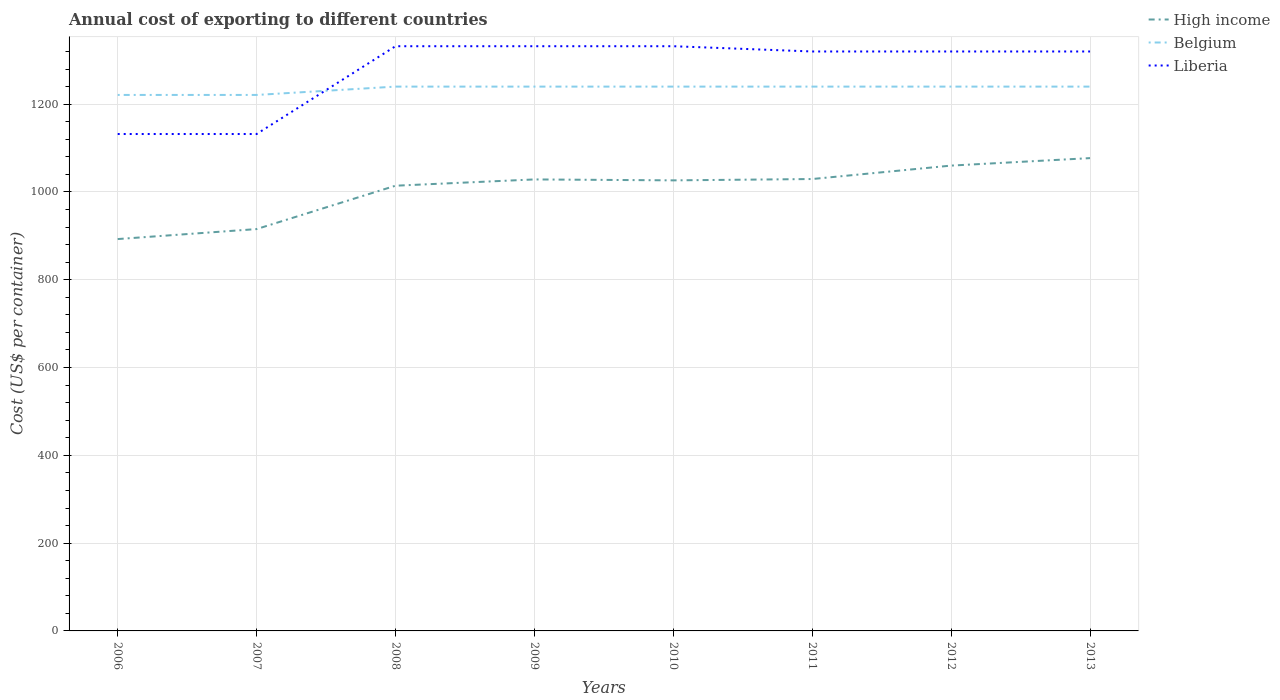Is the number of lines equal to the number of legend labels?
Provide a succinct answer. Yes. Across all years, what is the maximum total annual cost of exporting in High income?
Provide a succinct answer. 892.68. What is the difference between the highest and the second highest total annual cost of exporting in High income?
Give a very brief answer. 184.42. How many lines are there?
Your response must be concise. 3. How many years are there in the graph?
Your answer should be compact. 8. Does the graph contain any zero values?
Your answer should be very brief. No. How many legend labels are there?
Provide a succinct answer. 3. What is the title of the graph?
Make the answer very short. Annual cost of exporting to different countries. What is the label or title of the Y-axis?
Offer a terse response. Cost (US$ per container). What is the Cost (US$ per container) in High income in 2006?
Keep it short and to the point. 892.68. What is the Cost (US$ per container) in Belgium in 2006?
Your response must be concise. 1221. What is the Cost (US$ per container) in Liberia in 2006?
Make the answer very short. 1132. What is the Cost (US$ per container) in High income in 2007?
Provide a short and direct response. 915.43. What is the Cost (US$ per container) in Belgium in 2007?
Give a very brief answer. 1221. What is the Cost (US$ per container) of Liberia in 2007?
Your answer should be compact. 1132. What is the Cost (US$ per container) of High income in 2008?
Your answer should be compact. 1014.23. What is the Cost (US$ per container) of Belgium in 2008?
Provide a short and direct response. 1240. What is the Cost (US$ per container) of Liberia in 2008?
Make the answer very short. 1332. What is the Cost (US$ per container) in High income in 2009?
Your answer should be very brief. 1028.54. What is the Cost (US$ per container) of Belgium in 2009?
Ensure brevity in your answer.  1240. What is the Cost (US$ per container) in Liberia in 2009?
Give a very brief answer. 1332. What is the Cost (US$ per container) in High income in 2010?
Offer a terse response. 1026.4. What is the Cost (US$ per container) of Belgium in 2010?
Make the answer very short. 1240. What is the Cost (US$ per container) in Liberia in 2010?
Provide a short and direct response. 1332. What is the Cost (US$ per container) of High income in 2011?
Your answer should be compact. 1029.46. What is the Cost (US$ per container) in Belgium in 2011?
Keep it short and to the point. 1240. What is the Cost (US$ per container) in Liberia in 2011?
Ensure brevity in your answer.  1320. What is the Cost (US$ per container) in High income in 2012?
Make the answer very short. 1060.05. What is the Cost (US$ per container) in Belgium in 2012?
Ensure brevity in your answer.  1240. What is the Cost (US$ per container) in Liberia in 2012?
Ensure brevity in your answer.  1320. What is the Cost (US$ per container) of High income in 2013?
Your response must be concise. 1077.1. What is the Cost (US$ per container) in Belgium in 2013?
Provide a short and direct response. 1240. What is the Cost (US$ per container) of Liberia in 2013?
Make the answer very short. 1320. Across all years, what is the maximum Cost (US$ per container) in High income?
Give a very brief answer. 1077.1. Across all years, what is the maximum Cost (US$ per container) of Belgium?
Provide a short and direct response. 1240. Across all years, what is the maximum Cost (US$ per container) in Liberia?
Your answer should be compact. 1332. Across all years, what is the minimum Cost (US$ per container) in High income?
Give a very brief answer. 892.68. Across all years, what is the minimum Cost (US$ per container) of Belgium?
Offer a very short reply. 1221. Across all years, what is the minimum Cost (US$ per container) in Liberia?
Your answer should be compact. 1132. What is the total Cost (US$ per container) in High income in the graph?
Give a very brief answer. 8043.89. What is the total Cost (US$ per container) of Belgium in the graph?
Ensure brevity in your answer.  9882. What is the total Cost (US$ per container) in Liberia in the graph?
Make the answer very short. 1.02e+04. What is the difference between the Cost (US$ per container) in High income in 2006 and that in 2007?
Provide a succinct answer. -22.75. What is the difference between the Cost (US$ per container) in Belgium in 2006 and that in 2007?
Your answer should be compact. 0. What is the difference between the Cost (US$ per container) in High income in 2006 and that in 2008?
Your answer should be very brief. -121.55. What is the difference between the Cost (US$ per container) in Liberia in 2006 and that in 2008?
Keep it short and to the point. -200. What is the difference between the Cost (US$ per container) in High income in 2006 and that in 2009?
Provide a succinct answer. -135.86. What is the difference between the Cost (US$ per container) of Liberia in 2006 and that in 2009?
Give a very brief answer. -200. What is the difference between the Cost (US$ per container) of High income in 2006 and that in 2010?
Keep it short and to the point. -133.72. What is the difference between the Cost (US$ per container) in Belgium in 2006 and that in 2010?
Your response must be concise. -19. What is the difference between the Cost (US$ per container) of Liberia in 2006 and that in 2010?
Offer a very short reply. -200. What is the difference between the Cost (US$ per container) of High income in 2006 and that in 2011?
Your response must be concise. -136.78. What is the difference between the Cost (US$ per container) of Liberia in 2006 and that in 2011?
Make the answer very short. -188. What is the difference between the Cost (US$ per container) of High income in 2006 and that in 2012?
Offer a terse response. -167.37. What is the difference between the Cost (US$ per container) in Belgium in 2006 and that in 2012?
Make the answer very short. -19. What is the difference between the Cost (US$ per container) in Liberia in 2006 and that in 2012?
Your response must be concise. -188. What is the difference between the Cost (US$ per container) of High income in 2006 and that in 2013?
Provide a short and direct response. -184.42. What is the difference between the Cost (US$ per container) in Belgium in 2006 and that in 2013?
Offer a terse response. -19. What is the difference between the Cost (US$ per container) of Liberia in 2006 and that in 2013?
Keep it short and to the point. -188. What is the difference between the Cost (US$ per container) in High income in 2007 and that in 2008?
Offer a very short reply. -98.8. What is the difference between the Cost (US$ per container) of Belgium in 2007 and that in 2008?
Provide a succinct answer. -19. What is the difference between the Cost (US$ per container) in Liberia in 2007 and that in 2008?
Provide a short and direct response. -200. What is the difference between the Cost (US$ per container) in High income in 2007 and that in 2009?
Offer a terse response. -113.12. What is the difference between the Cost (US$ per container) in Liberia in 2007 and that in 2009?
Offer a terse response. -200. What is the difference between the Cost (US$ per container) of High income in 2007 and that in 2010?
Provide a succinct answer. -110.97. What is the difference between the Cost (US$ per container) of Belgium in 2007 and that in 2010?
Your answer should be very brief. -19. What is the difference between the Cost (US$ per container) of Liberia in 2007 and that in 2010?
Your answer should be very brief. -200. What is the difference between the Cost (US$ per container) in High income in 2007 and that in 2011?
Give a very brief answer. -114.03. What is the difference between the Cost (US$ per container) in Liberia in 2007 and that in 2011?
Your answer should be very brief. -188. What is the difference between the Cost (US$ per container) of High income in 2007 and that in 2012?
Give a very brief answer. -144.62. What is the difference between the Cost (US$ per container) in Liberia in 2007 and that in 2012?
Provide a succinct answer. -188. What is the difference between the Cost (US$ per container) in High income in 2007 and that in 2013?
Give a very brief answer. -161.67. What is the difference between the Cost (US$ per container) of Belgium in 2007 and that in 2013?
Offer a terse response. -19. What is the difference between the Cost (US$ per container) of Liberia in 2007 and that in 2013?
Offer a very short reply. -188. What is the difference between the Cost (US$ per container) of High income in 2008 and that in 2009?
Give a very brief answer. -14.32. What is the difference between the Cost (US$ per container) in High income in 2008 and that in 2010?
Keep it short and to the point. -12.18. What is the difference between the Cost (US$ per container) of High income in 2008 and that in 2011?
Provide a short and direct response. -15.23. What is the difference between the Cost (US$ per container) of High income in 2008 and that in 2012?
Keep it short and to the point. -45.82. What is the difference between the Cost (US$ per container) in Belgium in 2008 and that in 2012?
Make the answer very short. 0. What is the difference between the Cost (US$ per container) of High income in 2008 and that in 2013?
Make the answer very short. -62.87. What is the difference between the Cost (US$ per container) in Belgium in 2008 and that in 2013?
Offer a terse response. 0. What is the difference between the Cost (US$ per container) in High income in 2009 and that in 2010?
Provide a succinct answer. 2.14. What is the difference between the Cost (US$ per container) of Belgium in 2009 and that in 2010?
Offer a very short reply. 0. What is the difference between the Cost (US$ per container) of Liberia in 2009 and that in 2010?
Make the answer very short. 0. What is the difference between the Cost (US$ per container) of High income in 2009 and that in 2011?
Provide a succinct answer. -0.91. What is the difference between the Cost (US$ per container) of Belgium in 2009 and that in 2011?
Your response must be concise. 0. What is the difference between the Cost (US$ per container) of Liberia in 2009 and that in 2011?
Your answer should be very brief. 12. What is the difference between the Cost (US$ per container) of High income in 2009 and that in 2012?
Provide a short and direct response. -31.51. What is the difference between the Cost (US$ per container) of Belgium in 2009 and that in 2012?
Make the answer very short. 0. What is the difference between the Cost (US$ per container) of High income in 2009 and that in 2013?
Offer a terse response. -48.55. What is the difference between the Cost (US$ per container) in Liberia in 2009 and that in 2013?
Ensure brevity in your answer.  12. What is the difference between the Cost (US$ per container) in High income in 2010 and that in 2011?
Provide a succinct answer. -3.05. What is the difference between the Cost (US$ per container) in High income in 2010 and that in 2012?
Provide a succinct answer. -33.65. What is the difference between the Cost (US$ per container) of Belgium in 2010 and that in 2012?
Your response must be concise. 0. What is the difference between the Cost (US$ per container) in Liberia in 2010 and that in 2012?
Offer a very short reply. 12. What is the difference between the Cost (US$ per container) in High income in 2010 and that in 2013?
Your answer should be very brief. -50.69. What is the difference between the Cost (US$ per container) of Liberia in 2010 and that in 2013?
Your answer should be compact. 12. What is the difference between the Cost (US$ per container) of High income in 2011 and that in 2012?
Your answer should be very brief. -30.59. What is the difference between the Cost (US$ per container) of Liberia in 2011 and that in 2012?
Offer a terse response. 0. What is the difference between the Cost (US$ per container) of High income in 2011 and that in 2013?
Your answer should be compact. -47.64. What is the difference between the Cost (US$ per container) of Belgium in 2011 and that in 2013?
Your answer should be very brief. 0. What is the difference between the Cost (US$ per container) in High income in 2012 and that in 2013?
Provide a short and direct response. -17.05. What is the difference between the Cost (US$ per container) in Liberia in 2012 and that in 2013?
Your answer should be very brief. 0. What is the difference between the Cost (US$ per container) in High income in 2006 and the Cost (US$ per container) in Belgium in 2007?
Your answer should be compact. -328.32. What is the difference between the Cost (US$ per container) in High income in 2006 and the Cost (US$ per container) in Liberia in 2007?
Provide a short and direct response. -239.32. What is the difference between the Cost (US$ per container) of Belgium in 2006 and the Cost (US$ per container) of Liberia in 2007?
Your response must be concise. 89. What is the difference between the Cost (US$ per container) of High income in 2006 and the Cost (US$ per container) of Belgium in 2008?
Make the answer very short. -347.32. What is the difference between the Cost (US$ per container) in High income in 2006 and the Cost (US$ per container) in Liberia in 2008?
Keep it short and to the point. -439.32. What is the difference between the Cost (US$ per container) of Belgium in 2006 and the Cost (US$ per container) of Liberia in 2008?
Keep it short and to the point. -111. What is the difference between the Cost (US$ per container) in High income in 2006 and the Cost (US$ per container) in Belgium in 2009?
Provide a short and direct response. -347.32. What is the difference between the Cost (US$ per container) of High income in 2006 and the Cost (US$ per container) of Liberia in 2009?
Your answer should be very brief. -439.32. What is the difference between the Cost (US$ per container) in Belgium in 2006 and the Cost (US$ per container) in Liberia in 2009?
Offer a very short reply. -111. What is the difference between the Cost (US$ per container) of High income in 2006 and the Cost (US$ per container) of Belgium in 2010?
Offer a terse response. -347.32. What is the difference between the Cost (US$ per container) of High income in 2006 and the Cost (US$ per container) of Liberia in 2010?
Ensure brevity in your answer.  -439.32. What is the difference between the Cost (US$ per container) in Belgium in 2006 and the Cost (US$ per container) in Liberia in 2010?
Provide a succinct answer. -111. What is the difference between the Cost (US$ per container) in High income in 2006 and the Cost (US$ per container) in Belgium in 2011?
Make the answer very short. -347.32. What is the difference between the Cost (US$ per container) of High income in 2006 and the Cost (US$ per container) of Liberia in 2011?
Your answer should be very brief. -427.32. What is the difference between the Cost (US$ per container) of Belgium in 2006 and the Cost (US$ per container) of Liberia in 2011?
Make the answer very short. -99. What is the difference between the Cost (US$ per container) in High income in 2006 and the Cost (US$ per container) in Belgium in 2012?
Provide a short and direct response. -347.32. What is the difference between the Cost (US$ per container) of High income in 2006 and the Cost (US$ per container) of Liberia in 2012?
Provide a succinct answer. -427.32. What is the difference between the Cost (US$ per container) of Belgium in 2006 and the Cost (US$ per container) of Liberia in 2012?
Make the answer very short. -99. What is the difference between the Cost (US$ per container) in High income in 2006 and the Cost (US$ per container) in Belgium in 2013?
Keep it short and to the point. -347.32. What is the difference between the Cost (US$ per container) of High income in 2006 and the Cost (US$ per container) of Liberia in 2013?
Give a very brief answer. -427.32. What is the difference between the Cost (US$ per container) of Belgium in 2006 and the Cost (US$ per container) of Liberia in 2013?
Your response must be concise. -99. What is the difference between the Cost (US$ per container) in High income in 2007 and the Cost (US$ per container) in Belgium in 2008?
Keep it short and to the point. -324.57. What is the difference between the Cost (US$ per container) in High income in 2007 and the Cost (US$ per container) in Liberia in 2008?
Make the answer very short. -416.57. What is the difference between the Cost (US$ per container) of Belgium in 2007 and the Cost (US$ per container) of Liberia in 2008?
Give a very brief answer. -111. What is the difference between the Cost (US$ per container) of High income in 2007 and the Cost (US$ per container) of Belgium in 2009?
Give a very brief answer. -324.57. What is the difference between the Cost (US$ per container) in High income in 2007 and the Cost (US$ per container) in Liberia in 2009?
Offer a terse response. -416.57. What is the difference between the Cost (US$ per container) in Belgium in 2007 and the Cost (US$ per container) in Liberia in 2009?
Your answer should be compact. -111. What is the difference between the Cost (US$ per container) of High income in 2007 and the Cost (US$ per container) of Belgium in 2010?
Your response must be concise. -324.57. What is the difference between the Cost (US$ per container) of High income in 2007 and the Cost (US$ per container) of Liberia in 2010?
Make the answer very short. -416.57. What is the difference between the Cost (US$ per container) in Belgium in 2007 and the Cost (US$ per container) in Liberia in 2010?
Offer a very short reply. -111. What is the difference between the Cost (US$ per container) in High income in 2007 and the Cost (US$ per container) in Belgium in 2011?
Offer a terse response. -324.57. What is the difference between the Cost (US$ per container) in High income in 2007 and the Cost (US$ per container) in Liberia in 2011?
Offer a terse response. -404.57. What is the difference between the Cost (US$ per container) of Belgium in 2007 and the Cost (US$ per container) of Liberia in 2011?
Give a very brief answer. -99. What is the difference between the Cost (US$ per container) of High income in 2007 and the Cost (US$ per container) of Belgium in 2012?
Make the answer very short. -324.57. What is the difference between the Cost (US$ per container) of High income in 2007 and the Cost (US$ per container) of Liberia in 2012?
Provide a short and direct response. -404.57. What is the difference between the Cost (US$ per container) in Belgium in 2007 and the Cost (US$ per container) in Liberia in 2012?
Ensure brevity in your answer.  -99. What is the difference between the Cost (US$ per container) of High income in 2007 and the Cost (US$ per container) of Belgium in 2013?
Give a very brief answer. -324.57. What is the difference between the Cost (US$ per container) in High income in 2007 and the Cost (US$ per container) in Liberia in 2013?
Offer a very short reply. -404.57. What is the difference between the Cost (US$ per container) in Belgium in 2007 and the Cost (US$ per container) in Liberia in 2013?
Make the answer very short. -99. What is the difference between the Cost (US$ per container) in High income in 2008 and the Cost (US$ per container) in Belgium in 2009?
Keep it short and to the point. -225.77. What is the difference between the Cost (US$ per container) of High income in 2008 and the Cost (US$ per container) of Liberia in 2009?
Make the answer very short. -317.77. What is the difference between the Cost (US$ per container) in Belgium in 2008 and the Cost (US$ per container) in Liberia in 2009?
Provide a short and direct response. -92. What is the difference between the Cost (US$ per container) of High income in 2008 and the Cost (US$ per container) of Belgium in 2010?
Keep it short and to the point. -225.77. What is the difference between the Cost (US$ per container) in High income in 2008 and the Cost (US$ per container) in Liberia in 2010?
Your answer should be very brief. -317.77. What is the difference between the Cost (US$ per container) of Belgium in 2008 and the Cost (US$ per container) of Liberia in 2010?
Your response must be concise. -92. What is the difference between the Cost (US$ per container) of High income in 2008 and the Cost (US$ per container) of Belgium in 2011?
Offer a terse response. -225.77. What is the difference between the Cost (US$ per container) of High income in 2008 and the Cost (US$ per container) of Liberia in 2011?
Keep it short and to the point. -305.77. What is the difference between the Cost (US$ per container) of Belgium in 2008 and the Cost (US$ per container) of Liberia in 2011?
Your answer should be compact. -80. What is the difference between the Cost (US$ per container) of High income in 2008 and the Cost (US$ per container) of Belgium in 2012?
Offer a terse response. -225.77. What is the difference between the Cost (US$ per container) of High income in 2008 and the Cost (US$ per container) of Liberia in 2012?
Your answer should be very brief. -305.77. What is the difference between the Cost (US$ per container) in Belgium in 2008 and the Cost (US$ per container) in Liberia in 2012?
Your response must be concise. -80. What is the difference between the Cost (US$ per container) of High income in 2008 and the Cost (US$ per container) of Belgium in 2013?
Your answer should be very brief. -225.77. What is the difference between the Cost (US$ per container) in High income in 2008 and the Cost (US$ per container) in Liberia in 2013?
Keep it short and to the point. -305.77. What is the difference between the Cost (US$ per container) in Belgium in 2008 and the Cost (US$ per container) in Liberia in 2013?
Provide a succinct answer. -80. What is the difference between the Cost (US$ per container) in High income in 2009 and the Cost (US$ per container) in Belgium in 2010?
Ensure brevity in your answer.  -211.46. What is the difference between the Cost (US$ per container) of High income in 2009 and the Cost (US$ per container) of Liberia in 2010?
Ensure brevity in your answer.  -303.46. What is the difference between the Cost (US$ per container) in Belgium in 2009 and the Cost (US$ per container) in Liberia in 2010?
Your answer should be compact. -92. What is the difference between the Cost (US$ per container) of High income in 2009 and the Cost (US$ per container) of Belgium in 2011?
Provide a succinct answer. -211.46. What is the difference between the Cost (US$ per container) in High income in 2009 and the Cost (US$ per container) in Liberia in 2011?
Keep it short and to the point. -291.46. What is the difference between the Cost (US$ per container) of Belgium in 2009 and the Cost (US$ per container) of Liberia in 2011?
Ensure brevity in your answer.  -80. What is the difference between the Cost (US$ per container) of High income in 2009 and the Cost (US$ per container) of Belgium in 2012?
Your answer should be very brief. -211.46. What is the difference between the Cost (US$ per container) in High income in 2009 and the Cost (US$ per container) in Liberia in 2012?
Your answer should be very brief. -291.46. What is the difference between the Cost (US$ per container) of Belgium in 2009 and the Cost (US$ per container) of Liberia in 2012?
Ensure brevity in your answer.  -80. What is the difference between the Cost (US$ per container) in High income in 2009 and the Cost (US$ per container) in Belgium in 2013?
Your answer should be compact. -211.46. What is the difference between the Cost (US$ per container) in High income in 2009 and the Cost (US$ per container) in Liberia in 2013?
Offer a terse response. -291.46. What is the difference between the Cost (US$ per container) of Belgium in 2009 and the Cost (US$ per container) of Liberia in 2013?
Offer a terse response. -80. What is the difference between the Cost (US$ per container) of High income in 2010 and the Cost (US$ per container) of Belgium in 2011?
Keep it short and to the point. -213.6. What is the difference between the Cost (US$ per container) in High income in 2010 and the Cost (US$ per container) in Liberia in 2011?
Provide a succinct answer. -293.6. What is the difference between the Cost (US$ per container) of Belgium in 2010 and the Cost (US$ per container) of Liberia in 2011?
Ensure brevity in your answer.  -80. What is the difference between the Cost (US$ per container) of High income in 2010 and the Cost (US$ per container) of Belgium in 2012?
Offer a terse response. -213.6. What is the difference between the Cost (US$ per container) of High income in 2010 and the Cost (US$ per container) of Liberia in 2012?
Give a very brief answer. -293.6. What is the difference between the Cost (US$ per container) of Belgium in 2010 and the Cost (US$ per container) of Liberia in 2012?
Ensure brevity in your answer.  -80. What is the difference between the Cost (US$ per container) of High income in 2010 and the Cost (US$ per container) of Belgium in 2013?
Offer a terse response. -213.6. What is the difference between the Cost (US$ per container) in High income in 2010 and the Cost (US$ per container) in Liberia in 2013?
Provide a short and direct response. -293.6. What is the difference between the Cost (US$ per container) of Belgium in 2010 and the Cost (US$ per container) of Liberia in 2013?
Your response must be concise. -80. What is the difference between the Cost (US$ per container) in High income in 2011 and the Cost (US$ per container) in Belgium in 2012?
Provide a succinct answer. -210.54. What is the difference between the Cost (US$ per container) of High income in 2011 and the Cost (US$ per container) of Liberia in 2012?
Your response must be concise. -290.54. What is the difference between the Cost (US$ per container) in Belgium in 2011 and the Cost (US$ per container) in Liberia in 2012?
Ensure brevity in your answer.  -80. What is the difference between the Cost (US$ per container) of High income in 2011 and the Cost (US$ per container) of Belgium in 2013?
Your answer should be very brief. -210.54. What is the difference between the Cost (US$ per container) of High income in 2011 and the Cost (US$ per container) of Liberia in 2013?
Make the answer very short. -290.54. What is the difference between the Cost (US$ per container) of Belgium in 2011 and the Cost (US$ per container) of Liberia in 2013?
Provide a short and direct response. -80. What is the difference between the Cost (US$ per container) of High income in 2012 and the Cost (US$ per container) of Belgium in 2013?
Your answer should be very brief. -179.95. What is the difference between the Cost (US$ per container) in High income in 2012 and the Cost (US$ per container) in Liberia in 2013?
Your answer should be compact. -259.95. What is the difference between the Cost (US$ per container) in Belgium in 2012 and the Cost (US$ per container) in Liberia in 2013?
Make the answer very short. -80. What is the average Cost (US$ per container) of High income per year?
Provide a short and direct response. 1005.49. What is the average Cost (US$ per container) in Belgium per year?
Offer a very short reply. 1235.25. What is the average Cost (US$ per container) of Liberia per year?
Your answer should be very brief. 1277.5. In the year 2006, what is the difference between the Cost (US$ per container) of High income and Cost (US$ per container) of Belgium?
Your answer should be compact. -328.32. In the year 2006, what is the difference between the Cost (US$ per container) of High income and Cost (US$ per container) of Liberia?
Your answer should be very brief. -239.32. In the year 2006, what is the difference between the Cost (US$ per container) in Belgium and Cost (US$ per container) in Liberia?
Give a very brief answer. 89. In the year 2007, what is the difference between the Cost (US$ per container) of High income and Cost (US$ per container) of Belgium?
Keep it short and to the point. -305.57. In the year 2007, what is the difference between the Cost (US$ per container) in High income and Cost (US$ per container) in Liberia?
Give a very brief answer. -216.57. In the year 2007, what is the difference between the Cost (US$ per container) of Belgium and Cost (US$ per container) of Liberia?
Provide a succinct answer. 89. In the year 2008, what is the difference between the Cost (US$ per container) in High income and Cost (US$ per container) in Belgium?
Give a very brief answer. -225.77. In the year 2008, what is the difference between the Cost (US$ per container) of High income and Cost (US$ per container) of Liberia?
Make the answer very short. -317.77. In the year 2008, what is the difference between the Cost (US$ per container) of Belgium and Cost (US$ per container) of Liberia?
Ensure brevity in your answer.  -92. In the year 2009, what is the difference between the Cost (US$ per container) in High income and Cost (US$ per container) in Belgium?
Give a very brief answer. -211.46. In the year 2009, what is the difference between the Cost (US$ per container) of High income and Cost (US$ per container) of Liberia?
Keep it short and to the point. -303.46. In the year 2009, what is the difference between the Cost (US$ per container) in Belgium and Cost (US$ per container) in Liberia?
Give a very brief answer. -92. In the year 2010, what is the difference between the Cost (US$ per container) in High income and Cost (US$ per container) in Belgium?
Make the answer very short. -213.6. In the year 2010, what is the difference between the Cost (US$ per container) in High income and Cost (US$ per container) in Liberia?
Give a very brief answer. -305.6. In the year 2010, what is the difference between the Cost (US$ per container) in Belgium and Cost (US$ per container) in Liberia?
Offer a very short reply. -92. In the year 2011, what is the difference between the Cost (US$ per container) in High income and Cost (US$ per container) in Belgium?
Provide a short and direct response. -210.54. In the year 2011, what is the difference between the Cost (US$ per container) in High income and Cost (US$ per container) in Liberia?
Your response must be concise. -290.54. In the year 2011, what is the difference between the Cost (US$ per container) of Belgium and Cost (US$ per container) of Liberia?
Keep it short and to the point. -80. In the year 2012, what is the difference between the Cost (US$ per container) of High income and Cost (US$ per container) of Belgium?
Provide a succinct answer. -179.95. In the year 2012, what is the difference between the Cost (US$ per container) of High income and Cost (US$ per container) of Liberia?
Offer a very short reply. -259.95. In the year 2012, what is the difference between the Cost (US$ per container) of Belgium and Cost (US$ per container) of Liberia?
Give a very brief answer. -80. In the year 2013, what is the difference between the Cost (US$ per container) of High income and Cost (US$ per container) of Belgium?
Give a very brief answer. -162.9. In the year 2013, what is the difference between the Cost (US$ per container) in High income and Cost (US$ per container) in Liberia?
Your response must be concise. -242.9. In the year 2013, what is the difference between the Cost (US$ per container) of Belgium and Cost (US$ per container) of Liberia?
Provide a succinct answer. -80. What is the ratio of the Cost (US$ per container) in High income in 2006 to that in 2007?
Provide a succinct answer. 0.98. What is the ratio of the Cost (US$ per container) of High income in 2006 to that in 2008?
Provide a succinct answer. 0.88. What is the ratio of the Cost (US$ per container) in Belgium in 2006 to that in 2008?
Your response must be concise. 0.98. What is the ratio of the Cost (US$ per container) in Liberia in 2006 to that in 2008?
Keep it short and to the point. 0.85. What is the ratio of the Cost (US$ per container) in High income in 2006 to that in 2009?
Your answer should be very brief. 0.87. What is the ratio of the Cost (US$ per container) of Belgium in 2006 to that in 2009?
Make the answer very short. 0.98. What is the ratio of the Cost (US$ per container) of Liberia in 2006 to that in 2009?
Provide a short and direct response. 0.85. What is the ratio of the Cost (US$ per container) in High income in 2006 to that in 2010?
Ensure brevity in your answer.  0.87. What is the ratio of the Cost (US$ per container) of Belgium in 2006 to that in 2010?
Offer a very short reply. 0.98. What is the ratio of the Cost (US$ per container) in Liberia in 2006 to that in 2010?
Your response must be concise. 0.85. What is the ratio of the Cost (US$ per container) in High income in 2006 to that in 2011?
Your answer should be compact. 0.87. What is the ratio of the Cost (US$ per container) of Belgium in 2006 to that in 2011?
Your answer should be very brief. 0.98. What is the ratio of the Cost (US$ per container) of Liberia in 2006 to that in 2011?
Offer a very short reply. 0.86. What is the ratio of the Cost (US$ per container) of High income in 2006 to that in 2012?
Your answer should be very brief. 0.84. What is the ratio of the Cost (US$ per container) in Belgium in 2006 to that in 2012?
Give a very brief answer. 0.98. What is the ratio of the Cost (US$ per container) in Liberia in 2006 to that in 2012?
Provide a short and direct response. 0.86. What is the ratio of the Cost (US$ per container) of High income in 2006 to that in 2013?
Keep it short and to the point. 0.83. What is the ratio of the Cost (US$ per container) of Belgium in 2006 to that in 2013?
Ensure brevity in your answer.  0.98. What is the ratio of the Cost (US$ per container) in Liberia in 2006 to that in 2013?
Give a very brief answer. 0.86. What is the ratio of the Cost (US$ per container) in High income in 2007 to that in 2008?
Your response must be concise. 0.9. What is the ratio of the Cost (US$ per container) in Belgium in 2007 to that in 2008?
Make the answer very short. 0.98. What is the ratio of the Cost (US$ per container) of Liberia in 2007 to that in 2008?
Your response must be concise. 0.85. What is the ratio of the Cost (US$ per container) in High income in 2007 to that in 2009?
Your answer should be compact. 0.89. What is the ratio of the Cost (US$ per container) of Belgium in 2007 to that in 2009?
Offer a terse response. 0.98. What is the ratio of the Cost (US$ per container) in Liberia in 2007 to that in 2009?
Give a very brief answer. 0.85. What is the ratio of the Cost (US$ per container) in High income in 2007 to that in 2010?
Your answer should be compact. 0.89. What is the ratio of the Cost (US$ per container) of Belgium in 2007 to that in 2010?
Provide a succinct answer. 0.98. What is the ratio of the Cost (US$ per container) of Liberia in 2007 to that in 2010?
Your answer should be compact. 0.85. What is the ratio of the Cost (US$ per container) in High income in 2007 to that in 2011?
Your answer should be very brief. 0.89. What is the ratio of the Cost (US$ per container) of Belgium in 2007 to that in 2011?
Keep it short and to the point. 0.98. What is the ratio of the Cost (US$ per container) in Liberia in 2007 to that in 2011?
Make the answer very short. 0.86. What is the ratio of the Cost (US$ per container) of High income in 2007 to that in 2012?
Offer a very short reply. 0.86. What is the ratio of the Cost (US$ per container) of Belgium in 2007 to that in 2012?
Your answer should be very brief. 0.98. What is the ratio of the Cost (US$ per container) in Liberia in 2007 to that in 2012?
Provide a succinct answer. 0.86. What is the ratio of the Cost (US$ per container) in High income in 2007 to that in 2013?
Make the answer very short. 0.85. What is the ratio of the Cost (US$ per container) in Belgium in 2007 to that in 2013?
Your answer should be very brief. 0.98. What is the ratio of the Cost (US$ per container) in Liberia in 2007 to that in 2013?
Provide a short and direct response. 0.86. What is the ratio of the Cost (US$ per container) in High income in 2008 to that in 2009?
Make the answer very short. 0.99. What is the ratio of the Cost (US$ per container) in Belgium in 2008 to that in 2009?
Ensure brevity in your answer.  1. What is the ratio of the Cost (US$ per container) of Liberia in 2008 to that in 2009?
Provide a succinct answer. 1. What is the ratio of the Cost (US$ per container) in High income in 2008 to that in 2010?
Provide a short and direct response. 0.99. What is the ratio of the Cost (US$ per container) of Belgium in 2008 to that in 2010?
Your response must be concise. 1. What is the ratio of the Cost (US$ per container) in Liberia in 2008 to that in 2010?
Keep it short and to the point. 1. What is the ratio of the Cost (US$ per container) in High income in 2008 to that in 2011?
Provide a short and direct response. 0.99. What is the ratio of the Cost (US$ per container) of Belgium in 2008 to that in 2011?
Offer a terse response. 1. What is the ratio of the Cost (US$ per container) in Liberia in 2008 to that in 2011?
Offer a very short reply. 1.01. What is the ratio of the Cost (US$ per container) of High income in 2008 to that in 2012?
Ensure brevity in your answer.  0.96. What is the ratio of the Cost (US$ per container) of Belgium in 2008 to that in 2012?
Give a very brief answer. 1. What is the ratio of the Cost (US$ per container) of Liberia in 2008 to that in 2012?
Provide a succinct answer. 1.01. What is the ratio of the Cost (US$ per container) of High income in 2008 to that in 2013?
Your answer should be compact. 0.94. What is the ratio of the Cost (US$ per container) in Belgium in 2008 to that in 2013?
Ensure brevity in your answer.  1. What is the ratio of the Cost (US$ per container) in Liberia in 2008 to that in 2013?
Offer a terse response. 1.01. What is the ratio of the Cost (US$ per container) in Liberia in 2009 to that in 2011?
Offer a very short reply. 1.01. What is the ratio of the Cost (US$ per container) in High income in 2009 to that in 2012?
Your response must be concise. 0.97. What is the ratio of the Cost (US$ per container) in Liberia in 2009 to that in 2012?
Offer a terse response. 1.01. What is the ratio of the Cost (US$ per container) of High income in 2009 to that in 2013?
Provide a short and direct response. 0.95. What is the ratio of the Cost (US$ per container) in Belgium in 2009 to that in 2013?
Give a very brief answer. 1. What is the ratio of the Cost (US$ per container) of Liberia in 2009 to that in 2013?
Keep it short and to the point. 1.01. What is the ratio of the Cost (US$ per container) of Liberia in 2010 to that in 2011?
Your response must be concise. 1.01. What is the ratio of the Cost (US$ per container) of High income in 2010 to that in 2012?
Your answer should be compact. 0.97. What is the ratio of the Cost (US$ per container) in Belgium in 2010 to that in 2012?
Provide a succinct answer. 1. What is the ratio of the Cost (US$ per container) of Liberia in 2010 to that in 2012?
Give a very brief answer. 1.01. What is the ratio of the Cost (US$ per container) of High income in 2010 to that in 2013?
Offer a very short reply. 0.95. What is the ratio of the Cost (US$ per container) in Liberia in 2010 to that in 2013?
Offer a terse response. 1.01. What is the ratio of the Cost (US$ per container) in High income in 2011 to that in 2012?
Offer a terse response. 0.97. What is the ratio of the Cost (US$ per container) in Belgium in 2011 to that in 2012?
Give a very brief answer. 1. What is the ratio of the Cost (US$ per container) of Liberia in 2011 to that in 2012?
Ensure brevity in your answer.  1. What is the ratio of the Cost (US$ per container) in High income in 2011 to that in 2013?
Give a very brief answer. 0.96. What is the ratio of the Cost (US$ per container) in Belgium in 2011 to that in 2013?
Your response must be concise. 1. What is the ratio of the Cost (US$ per container) of High income in 2012 to that in 2013?
Offer a very short reply. 0.98. What is the ratio of the Cost (US$ per container) of Belgium in 2012 to that in 2013?
Give a very brief answer. 1. What is the ratio of the Cost (US$ per container) of Liberia in 2012 to that in 2013?
Make the answer very short. 1. What is the difference between the highest and the second highest Cost (US$ per container) of High income?
Your response must be concise. 17.05. What is the difference between the highest and the second highest Cost (US$ per container) of Liberia?
Your response must be concise. 0. What is the difference between the highest and the lowest Cost (US$ per container) in High income?
Offer a terse response. 184.42. What is the difference between the highest and the lowest Cost (US$ per container) of Belgium?
Give a very brief answer. 19. 